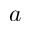<formula> <loc_0><loc_0><loc_500><loc_500>a</formula> 